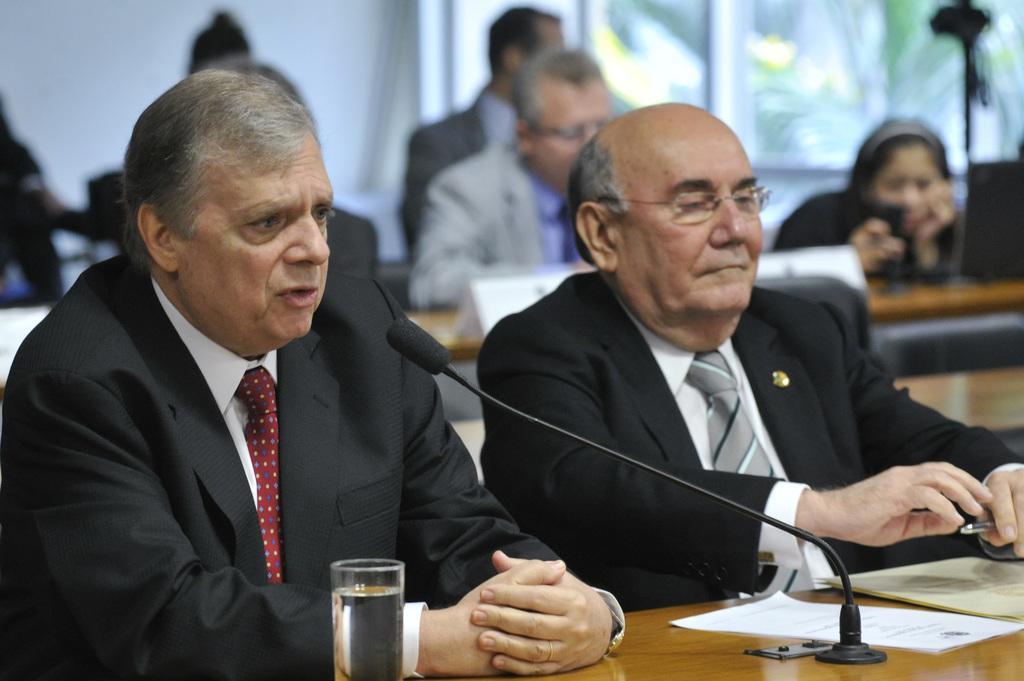Describe this image in one or two sentences. In the foreground of the image we can see two persons are sitting on chairs and one person is speaking something in front of the mike. On the top of the image we can see some people are sitting on chairs, but that image is in blue. 